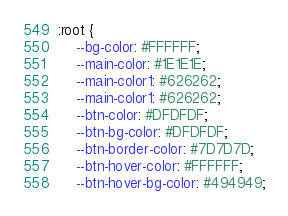Convert code to text. <code><loc_0><loc_0><loc_500><loc_500><_CSS_>:root {
    --bg-color: #FFFFFF;
    --main-color: #1E1E1E;
    --main-color1: #626262;
    --main-color1: #626262;
    --btn-color: #DFDFDF;
    --btn-bg-color: #DFDFDF;
    --btn-border-color: #7D7D7D;
    --btn-hover-color: #FFFFFF;
    --btn-hover-bg-color: #494949;</code> 